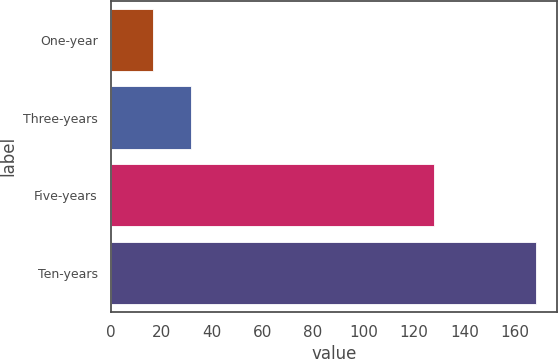<chart> <loc_0><loc_0><loc_500><loc_500><bar_chart><fcel>One-year<fcel>Three-years<fcel>Five-years<fcel>Ten-years<nl><fcel>16.8<fcel>31.93<fcel>128<fcel>168.1<nl></chart> 